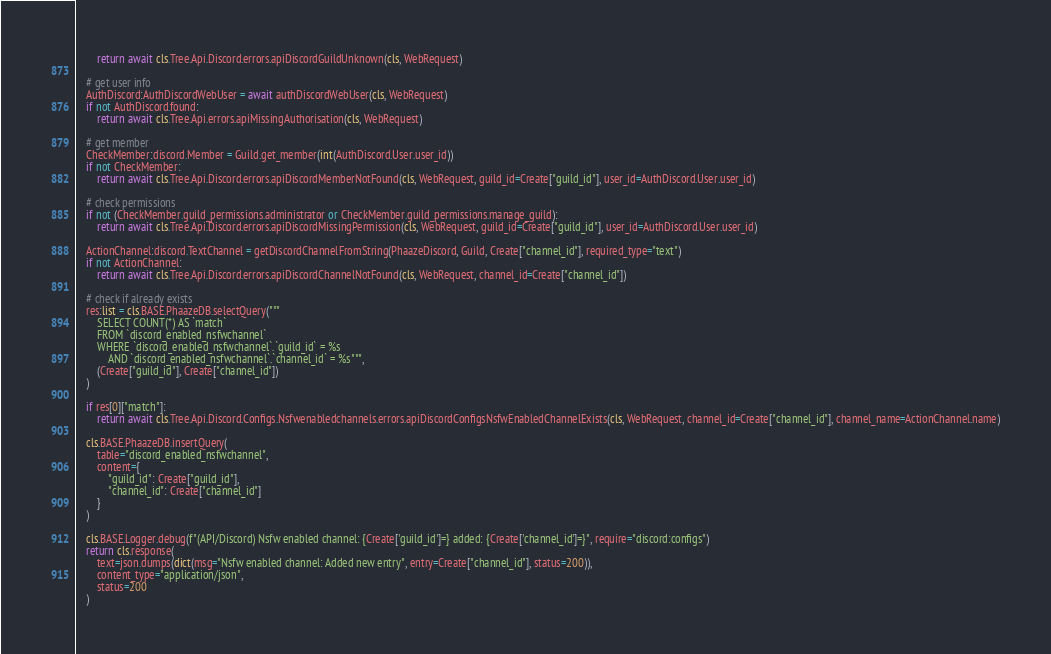Convert code to text. <code><loc_0><loc_0><loc_500><loc_500><_Python_>		return await cls.Tree.Api.Discord.errors.apiDiscordGuildUnknown(cls, WebRequest)

	# get user info
	AuthDiscord:AuthDiscordWebUser = await authDiscordWebUser(cls, WebRequest)
	if not AuthDiscord.found:
		return await cls.Tree.Api.errors.apiMissingAuthorisation(cls, WebRequest)

	# get member
	CheckMember:discord.Member = Guild.get_member(int(AuthDiscord.User.user_id))
	if not CheckMember:
		return await cls.Tree.Api.Discord.errors.apiDiscordMemberNotFound(cls, WebRequest, guild_id=Create["guild_id"], user_id=AuthDiscord.User.user_id)

	# check permissions
	if not (CheckMember.guild_permissions.administrator or CheckMember.guild_permissions.manage_guild):
		return await cls.Tree.Api.Discord.errors.apiDiscordMissingPermission(cls, WebRequest, guild_id=Create["guild_id"], user_id=AuthDiscord.User.user_id)

	ActionChannel:discord.TextChannel = getDiscordChannelFromString(PhaazeDiscord, Guild, Create["channel_id"], required_type="text")
	if not ActionChannel:
		return await cls.Tree.Api.Discord.errors.apiDiscordChannelNotFound(cls, WebRequest, channel_id=Create["channel_id"])

	# check if already exists
	res:list = cls.BASE.PhaazeDB.selectQuery("""
		SELECT COUNT(*) AS `match`
		FROM `discord_enabled_nsfwchannel`
		WHERE `discord_enabled_nsfwchannel`.`guild_id` = %s
			AND `discord_enabled_nsfwchannel`.`channel_id` = %s""",
		(Create["guild_id"], Create["channel_id"])
	)

	if res[0]["match"]:
		return await cls.Tree.Api.Discord.Configs.Nsfwenabledchannels.errors.apiDiscordConfigsNsfwEnabledChannelExists(cls, WebRequest, channel_id=Create["channel_id"], channel_name=ActionChannel.name)

	cls.BASE.PhaazeDB.insertQuery(
		table="discord_enabled_nsfwchannel",
		content={
			"guild_id": Create["guild_id"],
			"channel_id": Create["channel_id"]
		}
	)

	cls.BASE.Logger.debug(f"(API/Discord) Nsfw enabled channel: {Create['guild_id']=} added: {Create['channel_id']=}", require="discord:configs")
	return cls.response(
		text=json.dumps(dict(msg="Nsfw enabled channel: Added new entry", entry=Create["channel_id"], status=200)),
		content_type="application/json",
		status=200
	)
</code> 